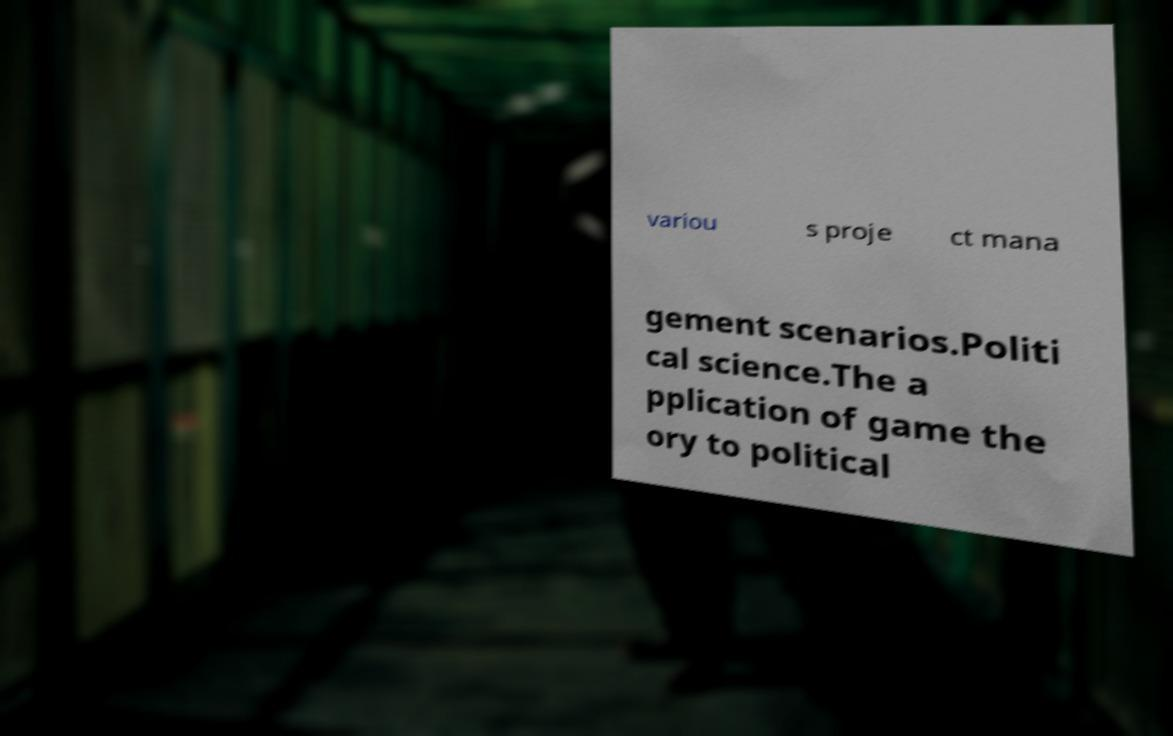For documentation purposes, I need the text within this image transcribed. Could you provide that? variou s proje ct mana gement scenarios.Politi cal science.The a pplication of game the ory to political 